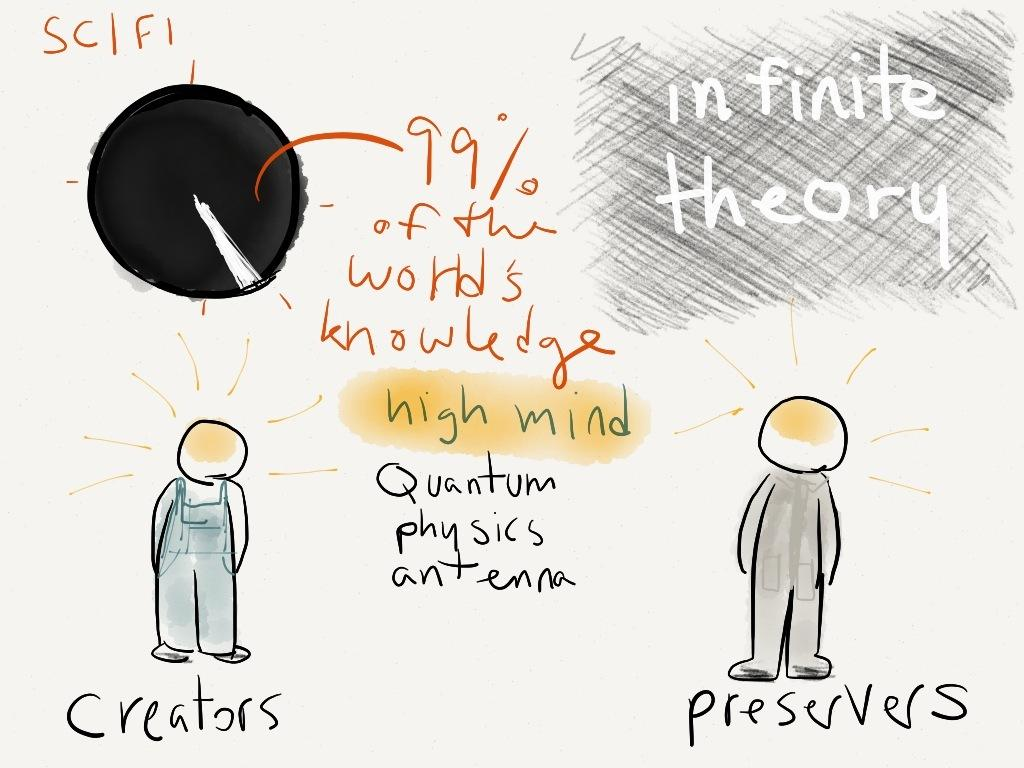What type of image is the poster in the image? The image is a poster. What is depicted on the poster? There are two cartoons on the poster. What else is featured on the poster besides the cartoons? There is text written on the poster. What type of lace is used to decorate the edges of the poster? There is no lace present on the poster; it only features cartoons and text. Is there a water fountain visible in the background of the poster? There is no water fountain or any reference to water in the poster; it only features cartoons and text. 